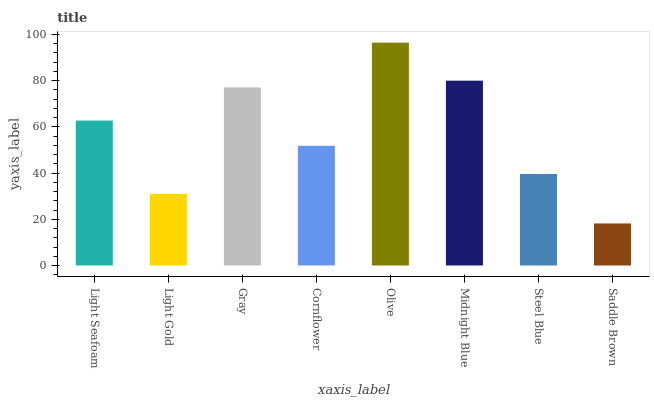Is Saddle Brown the minimum?
Answer yes or no. Yes. Is Olive the maximum?
Answer yes or no. Yes. Is Light Gold the minimum?
Answer yes or no. No. Is Light Gold the maximum?
Answer yes or no. No. Is Light Seafoam greater than Light Gold?
Answer yes or no. Yes. Is Light Gold less than Light Seafoam?
Answer yes or no. Yes. Is Light Gold greater than Light Seafoam?
Answer yes or no. No. Is Light Seafoam less than Light Gold?
Answer yes or no. No. Is Light Seafoam the high median?
Answer yes or no. Yes. Is Cornflower the low median?
Answer yes or no. Yes. Is Cornflower the high median?
Answer yes or no. No. Is Midnight Blue the low median?
Answer yes or no. No. 